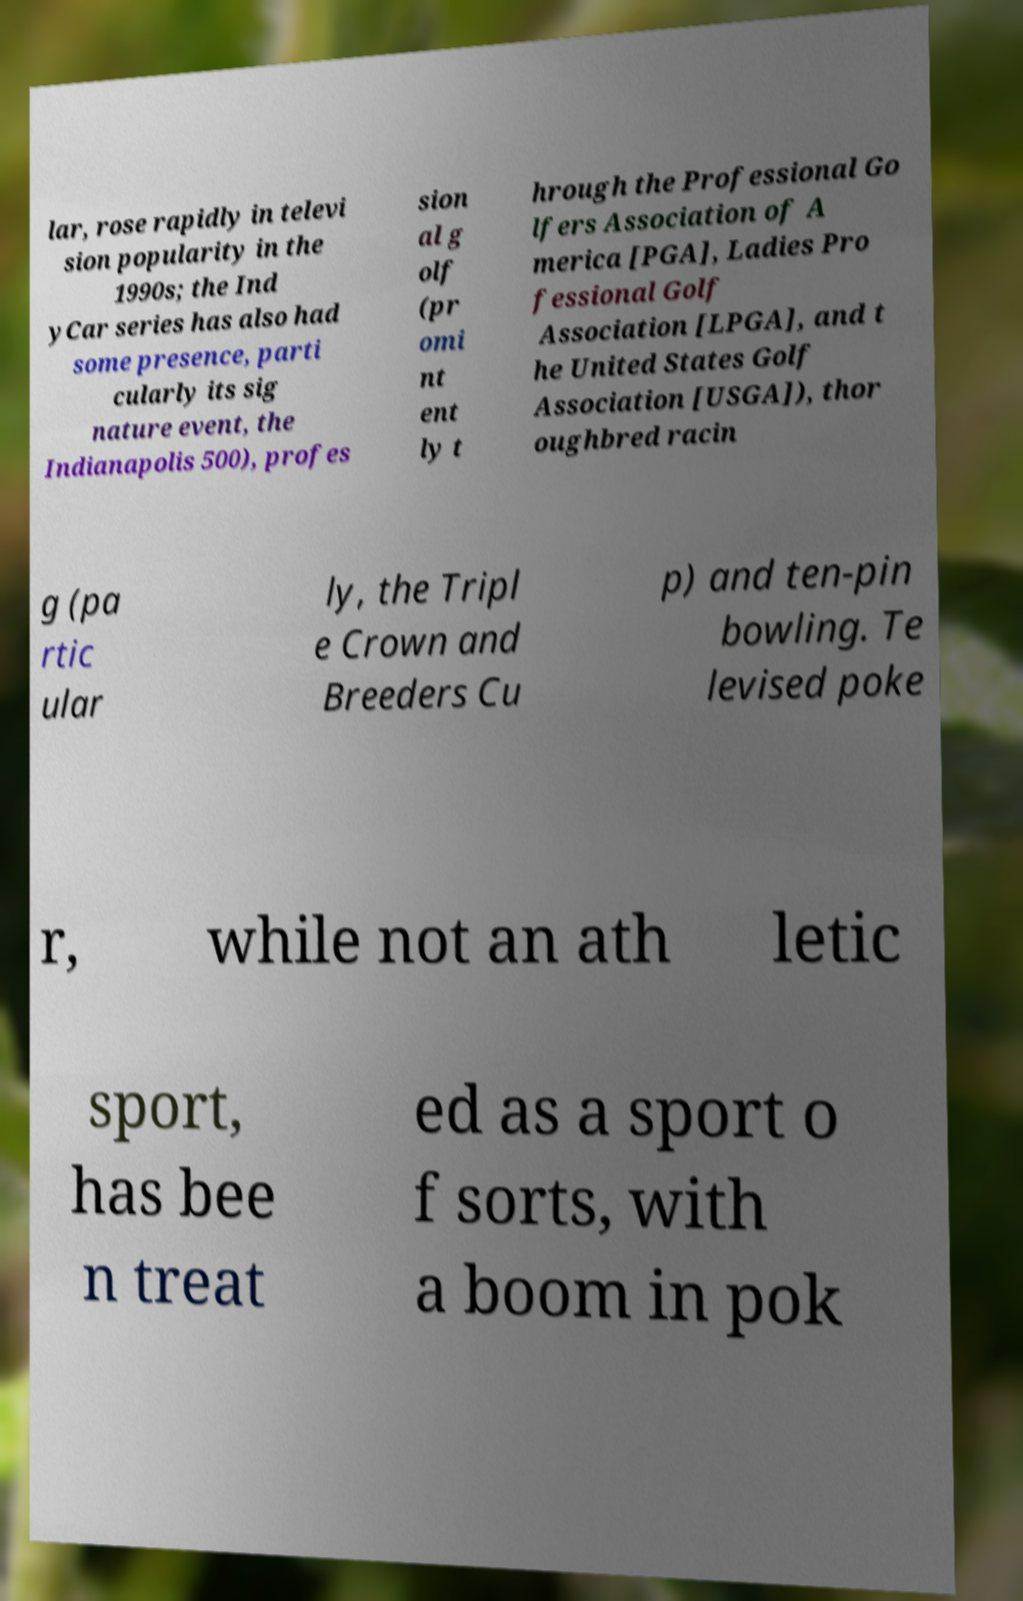What messages or text are displayed in this image? I need them in a readable, typed format. lar, rose rapidly in televi sion popularity in the 1990s; the Ind yCar series has also had some presence, parti cularly its sig nature event, the Indianapolis 500), profes sion al g olf (pr omi nt ent ly t hrough the Professional Go lfers Association of A merica [PGA], Ladies Pro fessional Golf Association [LPGA], and t he United States Golf Association [USGA]), thor oughbred racin g (pa rtic ular ly, the Tripl e Crown and Breeders Cu p) and ten-pin bowling. Te levised poke r, while not an ath letic sport, has bee n treat ed as a sport o f sorts, with a boom in pok 